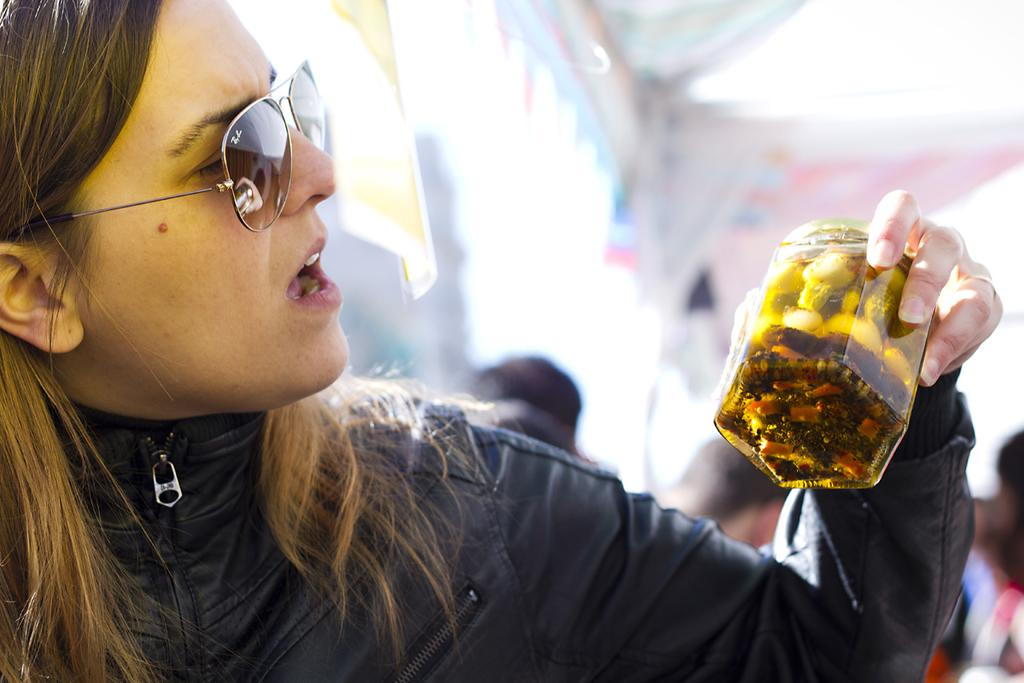What is the main subject of the image? The main subject of the image is a woman. What is the woman holding in the image? The woman is holding a jar in the image. What type of copper material can be seen in the image? There is no copper material present in the image. What is the distance between the woman and the jar in the image? The distance between the woman and the jar is not measurable from the image, as it is a two-dimensional representation. 